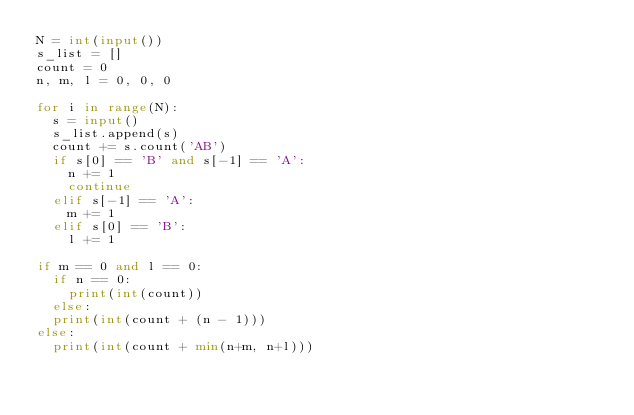<code> <loc_0><loc_0><loc_500><loc_500><_Python_>N = int(input())
s_list = []
count = 0
n, m, l = 0, 0, 0
 
for i in range(N):
  s = input()
  s_list.append(s)
  count += s.count('AB')
  if s[0] == 'B' and s[-1] == 'A':
    n += 1
    continue
  elif s[-1] == 'A':
    m += 1
  elif s[0] == 'B':
    l += 1

if m == 0 and l == 0:
  if n == 0:
    print(int(count))
  else:
  print(int(count + (n - 1)))
else:
  print(int(count + min(n+m, n+l)))</code> 